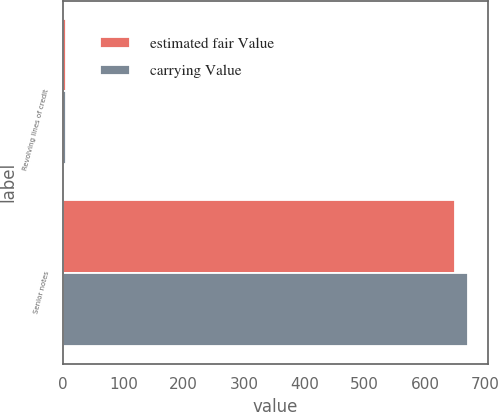<chart> <loc_0><loc_0><loc_500><loc_500><stacked_bar_chart><ecel><fcel>Revolving lines of credit<fcel>Senior notes<nl><fcel>estimated fair Value<fcel>5<fcel>649.2<nl><fcel>carrying Value<fcel>5<fcel>670.6<nl></chart> 